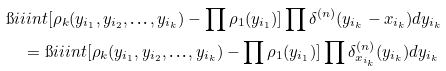Convert formula to latex. <formula><loc_0><loc_0><loc_500><loc_500>& \i i i i n t [ \rho _ { k } ( y _ { i _ { 1 } } , y _ { i _ { 2 } } , \text {\dots} , y _ { i _ { k } } ) - \prod \rho _ { 1 } ( y _ { i _ { 1 } } ) ] \prod \delta ^ { ( n ) } ( y _ { i _ { k } } - x _ { i _ { k } } ) d y _ { i _ { k } } \\ & \quad = \i i i i n t [ \rho _ { k } ( y _ { i _ { 1 } } , y _ { i _ { 2 } } , \text {\dots} , y _ { i _ { k } } ) - \prod \rho _ { 1 } ( y _ { i _ { 1 } } ) ] \prod \delta _ { x _ { i _ { k } } } ^ { ( n ) } ( y _ { i _ { k } } ) d y _ { i _ { k } }</formula> 